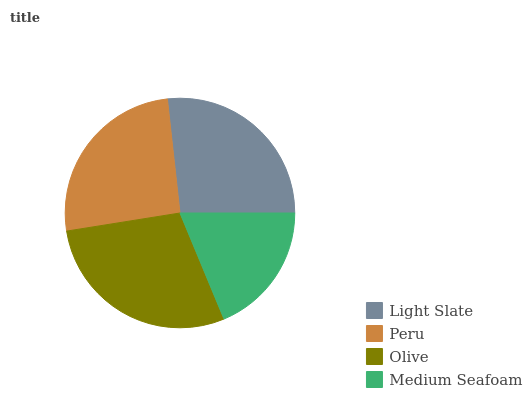Is Medium Seafoam the minimum?
Answer yes or no. Yes. Is Olive the maximum?
Answer yes or no. Yes. Is Peru the minimum?
Answer yes or no. No. Is Peru the maximum?
Answer yes or no. No. Is Light Slate greater than Peru?
Answer yes or no. Yes. Is Peru less than Light Slate?
Answer yes or no. Yes. Is Peru greater than Light Slate?
Answer yes or no. No. Is Light Slate less than Peru?
Answer yes or no. No. Is Light Slate the high median?
Answer yes or no. Yes. Is Peru the low median?
Answer yes or no. Yes. Is Olive the high median?
Answer yes or no. No. Is Light Slate the low median?
Answer yes or no. No. 